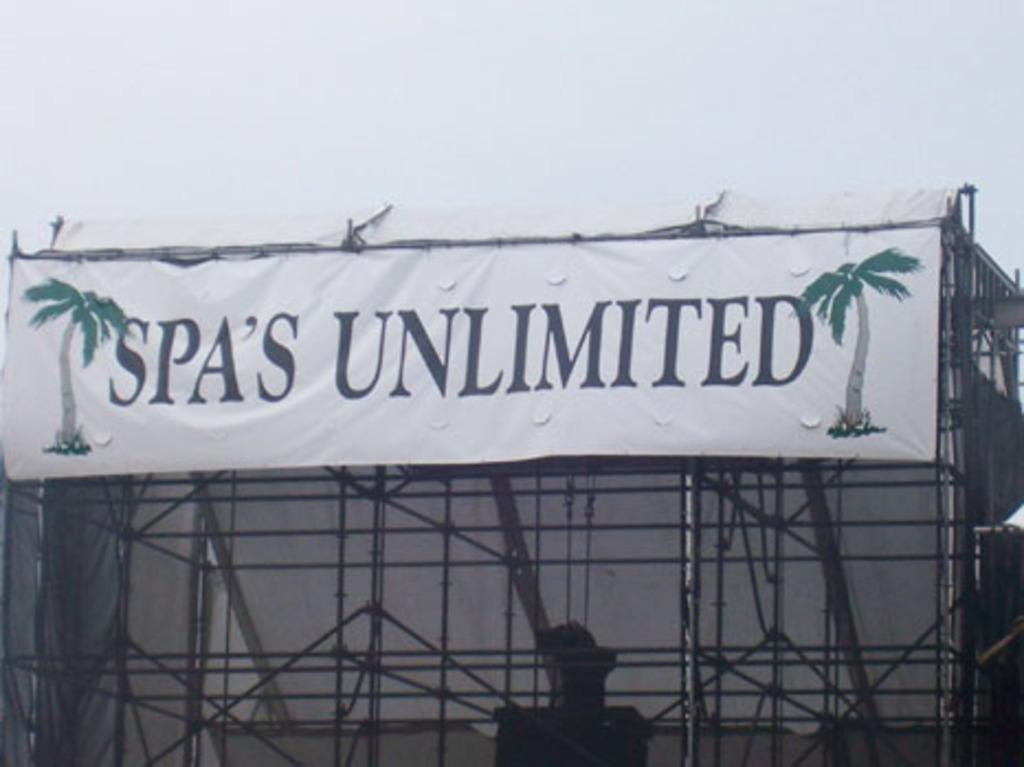Provide a one-sentence caption for the provided image. Spa's Unlimited is the advertiser for the stage show. 